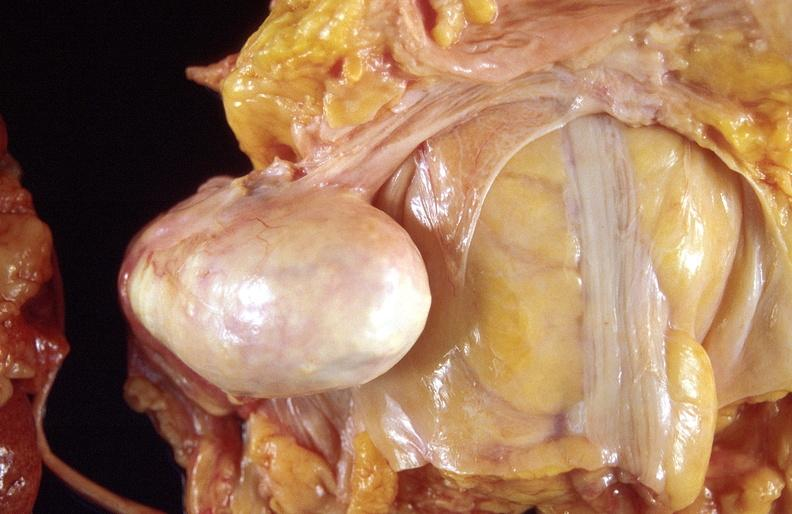where does this part belong to?
Answer the question using a single word or phrase. Female reproductive system 